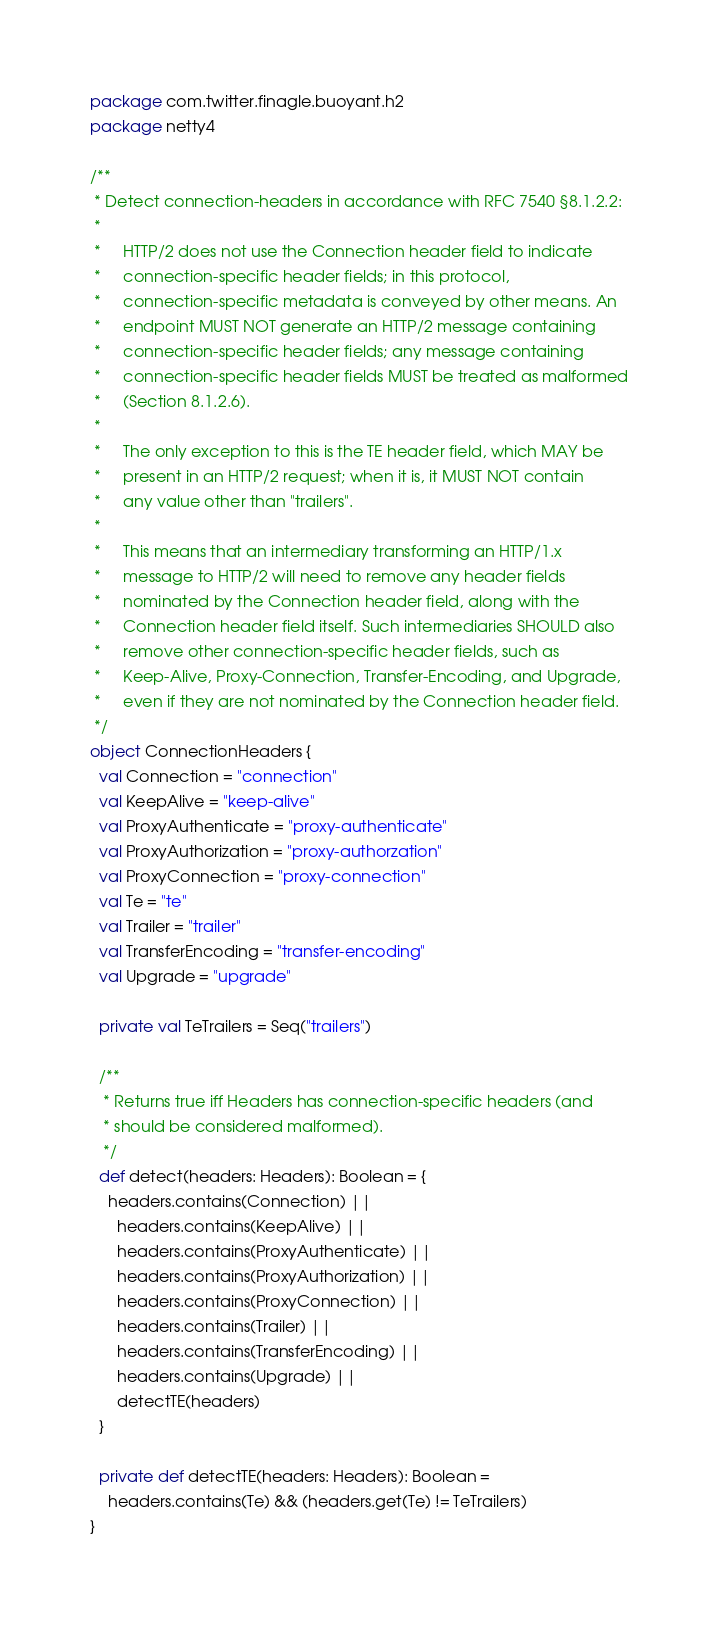Convert code to text. <code><loc_0><loc_0><loc_500><loc_500><_Scala_>package com.twitter.finagle.buoyant.h2
package netty4

/**
 * Detect connection-headers in accordance with RFC 7540 §8.1.2.2:
 *
 *     HTTP/2 does not use the Connection header field to indicate
 *     connection-specific header fields; in this protocol,
 *     connection-specific metadata is conveyed by other means. An
 *     endpoint MUST NOT generate an HTTP/2 message containing
 *     connection-specific header fields; any message containing
 *     connection-specific header fields MUST be treated as malformed
 *     (Section 8.1.2.6).
 *
 *     The only exception to this is the TE header field, which MAY be
 *     present in an HTTP/2 request; when it is, it MUST NOT contain
 *     any value other than "trailers".
 *
 *     This means that an intermediary transforming an HTTP/1.x
 *     message to HTTP/2 will need to remove any header fields
 *     nominated by the Connection header field, along with the
 *     Connection header field itself. Such intermediaries SHOULD also
 *     remove other connection-specific header fields, such as
 *     Keep-Alive, Proxy-Connection, Transfer-Encoding, and Upgrade,
 *     even if they are not nominated by the Connection header field.
 */
object ConnectionHeaders {
  val Connection = "connection"
  val KeepAlive = "keep-alive"
  val ProxyAuthenticate = "proxy-authenticate"
  val ProxyAuthorization = "proxy-authorzation"
  val ProxyConnection = "proxy-connection"
  val Te = "te"
  val Trailer = "trailer"
  val TransferEncoding = "transfer-encoding"
  val Upgrade = "upgrade"

  private val TeTrailers = Seq("trailers")

  /**
   * Returns true iff Headers has connection-specific headers (and
   * should be considered malformed).
   */
  def detect(headers: Headers): Boolean = {
    headers.contains(Connection) ||
      headers.contains(KeepAlive) ||
      headers.contains(ProxyAuthenticate) ||
      headers.contains(ProxyAuthorization) ||
      headers.contains(ProxyConnection) ||
      headers.contains(Trailer) ||
      headers.contains(TransferEncoding) ||
      headers.contains(Upgrade) ||
      detectTE(headers)
  }

  private def detectTE(headers: Headers): Boolean =
    headers.contains(Te) && (headers.get(Te) != TeTrailers)
}
</code> 